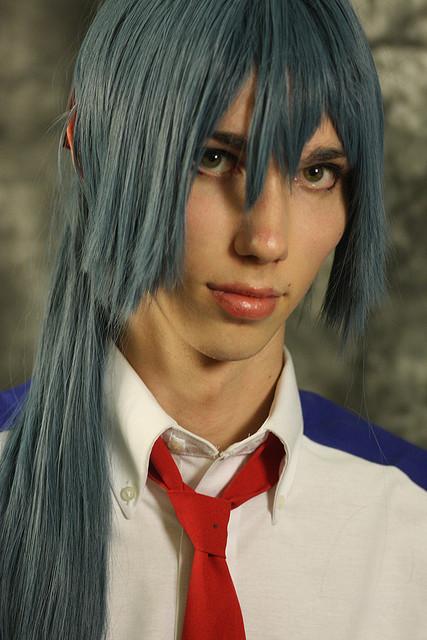Where is a red tie?
Short answer required. Around neck. What color is his hair?
Be succinct. Blue. Does this man have facial hair?
Write a very short answer. No. What is the woman wearing that mostly men wear?
Short answer required. Tie. Why might this be a wig?
Concise answer only. It looks fake. 